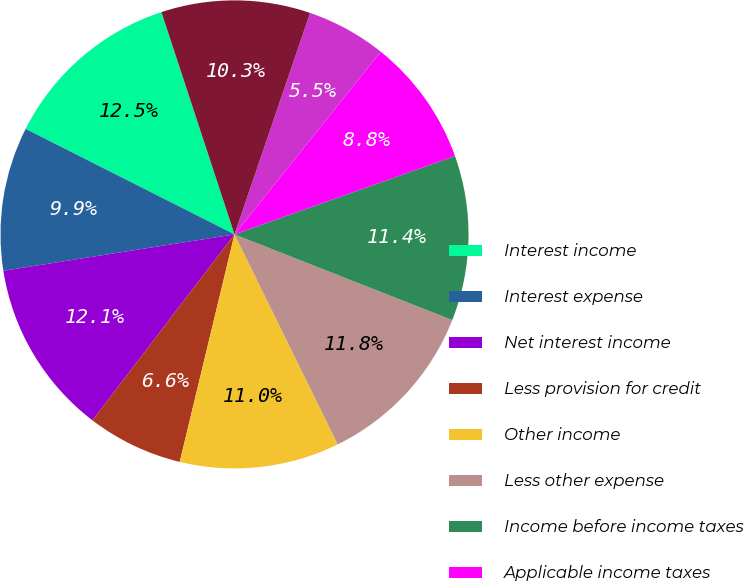Convert chart to OTSL. <chart><loc_0><loc_0><loc_500><loc_500><pie_chart><fcel>Interest income<fcel>Interest expense<fcel>Net interest income<fcel>Less provision for credit<fcel>Other income<fcel>Less other expense<fcel>Income before income taxes<fcel>Applicable income taxes<fcel>Taxable-equivalent adjustment<fcel>Net income<nl><fcel>12.5%<fcel>9.93%<fcel>12.13%<fcel>6.62%<fcel>11.03%<fcel>11.76%<fcel>11.4%<fcel>8.82%<fcel>5.51%<fcel>10.29%<nl></chart> 